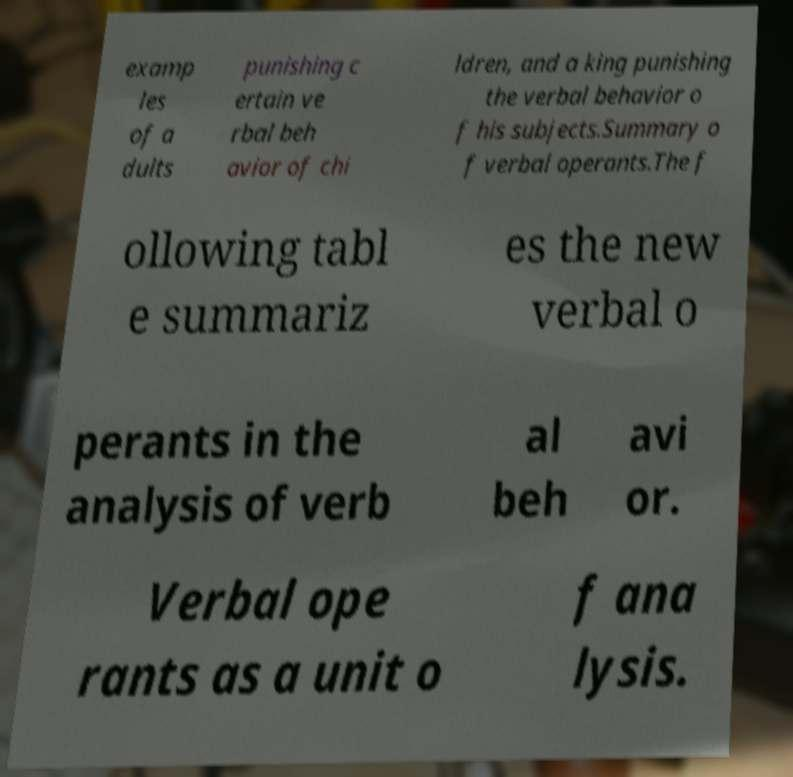I need the written content from this picture converted into text. Can you do that? examp les of a dults punishing c ertain ve rbal beh avior of chi ldren, and a king punishing the verbal behavior o f his subjects.Summary o f verbal operants.The f ollowing tabl e summariz es the new verbal o perants in the analysis of verb al beh avi or. Verbal ope rants as a unit o f ana lysis. 